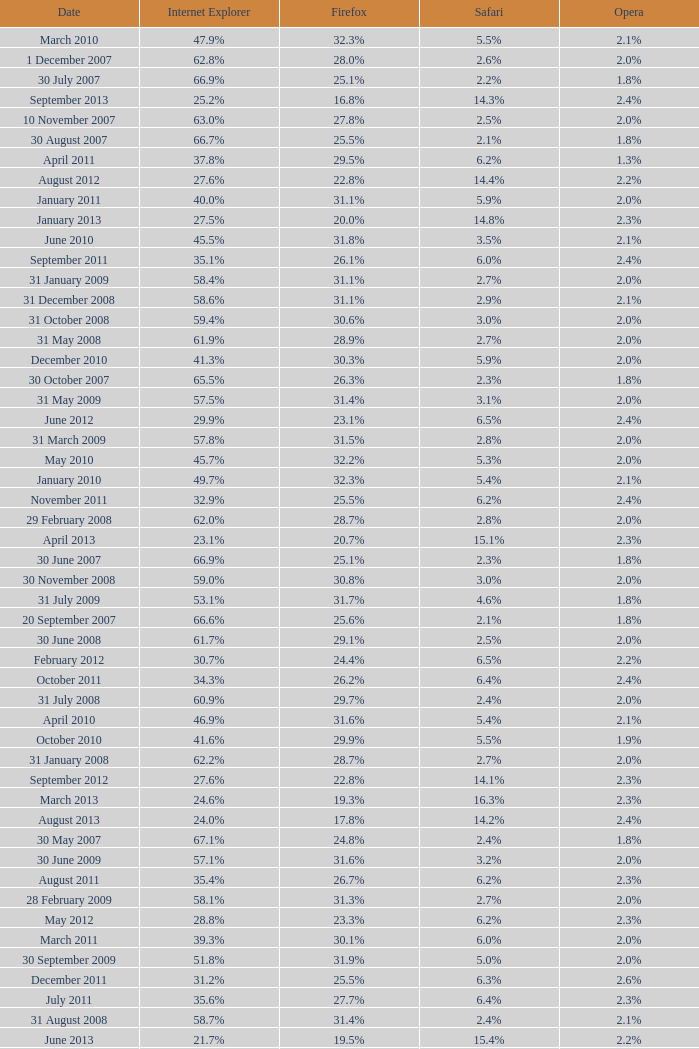What is the safari value with a 28.0% internet explorer? 14.3%. 